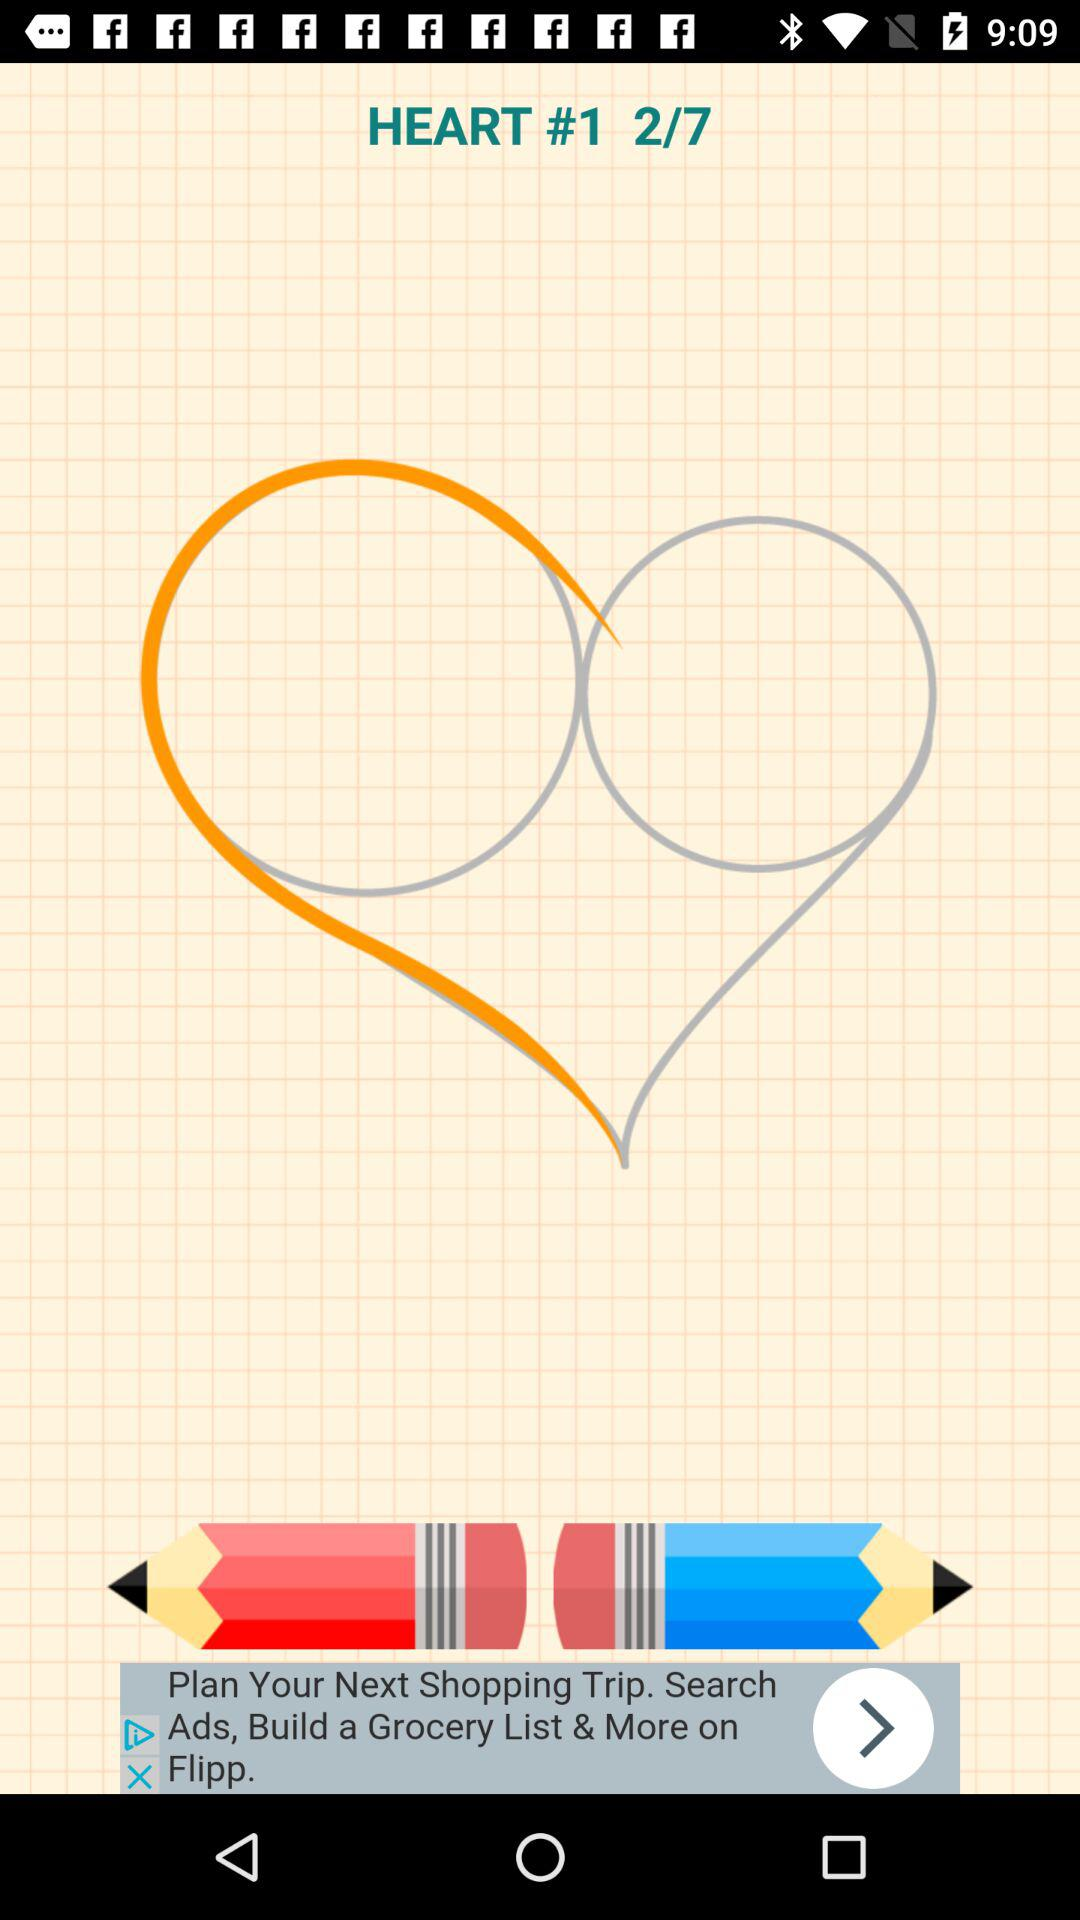What is the total number of steps? The total number of steps is 7. 